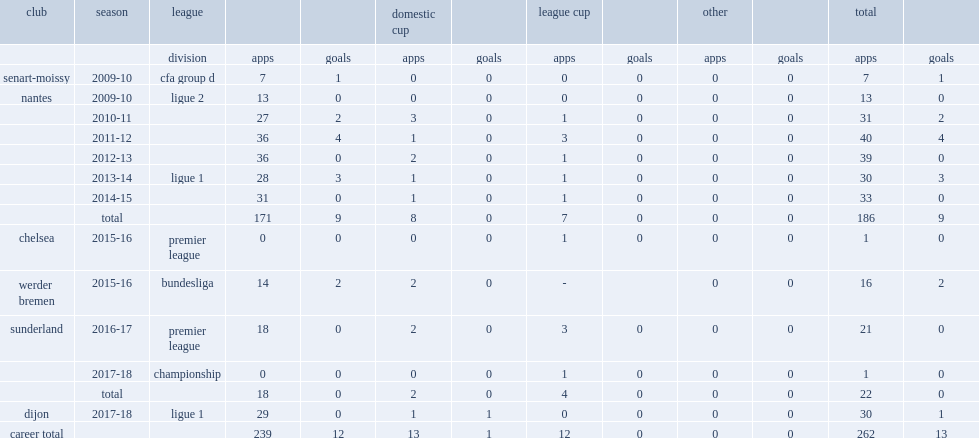How many goals did he score in 2010-11? 2.0. Can you parse all the data within this table? {'header': ['club', 'season', 'league', '', '', 'domestic cup', '', 'league cup', '', 'other', '', 'total', ''], 'rows': [['', '', 'division', 'apps', 'goals', 'apps', 'goals', 'apps', 'goals', 'apps', 'goals', 'apps', 'goals'], ['senart-moissy', '2009-10', 'cfa group d', '7', '1', '0', '0', '0', '0', '0', '0', '7', '1'], ['nantes', '2009-10', 'ligue 2', '13', '0', '0', '0', '0', '0', '0', '0', '13', '0'], ['', '2010-11', '', '27', '2', '3', '0', '1', '0', '0', '0', '31', '2'], ['', '2011-12', '', '36', '4', '1', '0', '3', '0', '0', '0', '40', '4'], ['', '2012-13', '', '36', '0', '2', '0', '1', '0', '0', '0', '39', '0'], ['', '2013-14', 'ligue 1', '28', '3', '1', '0', '1', '0', '0', '0', '30', '3'], ['', '2014-15', '', '31', '0', '1', '0', '1', '0', '0', '0', '33', '0'], ['', 'total', '', '171', '9', '8', '0', '7', '0', '0', '0', '186', '9'], ['chelsea', '2015-16', 'premier league', '0', '0', '0', '0', '1', '0', '0', '0', '1', '0'], ['werder bremen', '2015-16', 'bundesliga', '14', '2', '2', '0', '-', '', '0', '0', '16', '2'], ['sunderland', '2016-17', 'premier league', '18', '0', '2', '0', '3', '0', '0', '0', '21', '0'], ['', '2017-18', 'championship', '0', '0', '0', '0', '1', '0', '0', '0', '1', '0'], ['', 'total', '', '18', '0', '2', '0', '4', '0', '0', '0', '22', '0'], ['dijon', '2017-18', 'ligue 1', '29', '0', '1', '1', '0', '0', '0', '0', '30', '1'], ['career total', '', '', '239', '12', '13', '1', '12', '0', '0', '0', '262', '13']]} 